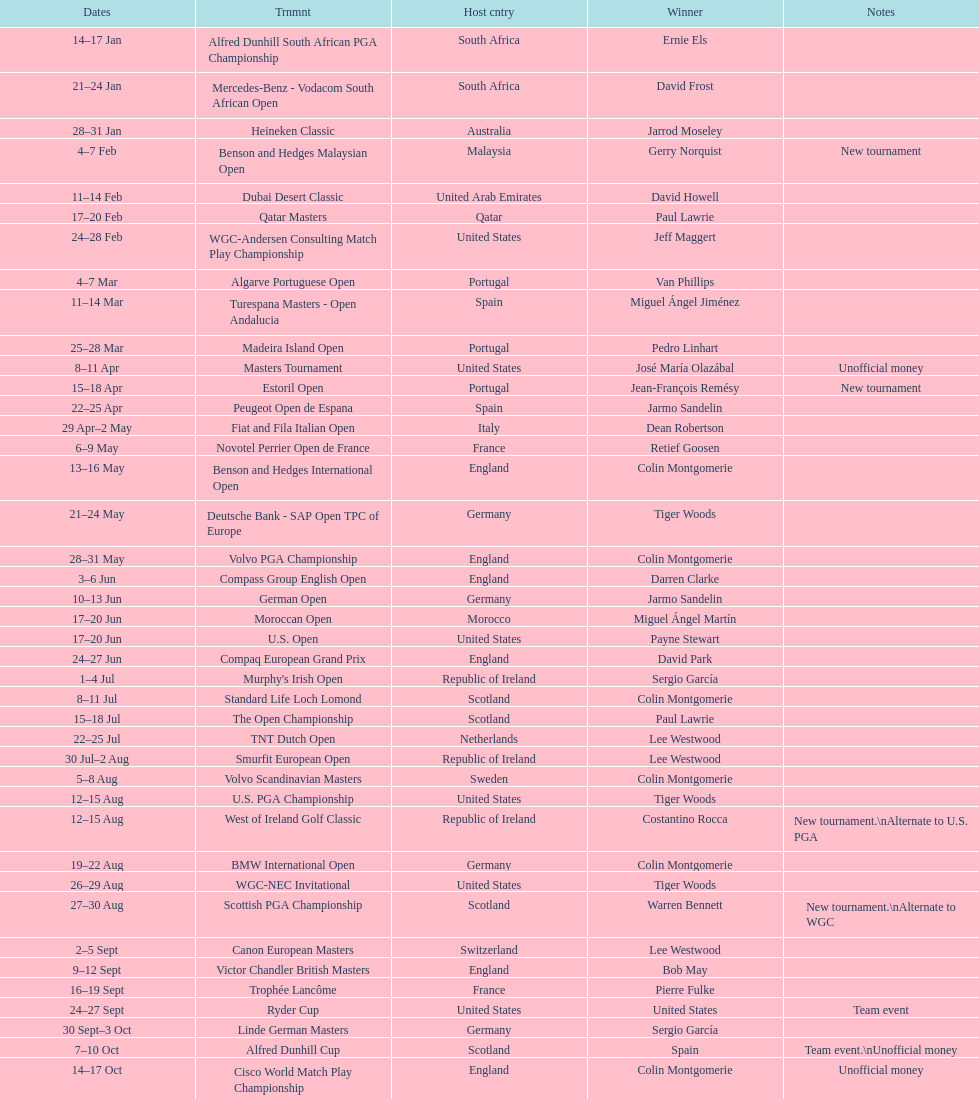How long did the estoril open last? 3 days. 